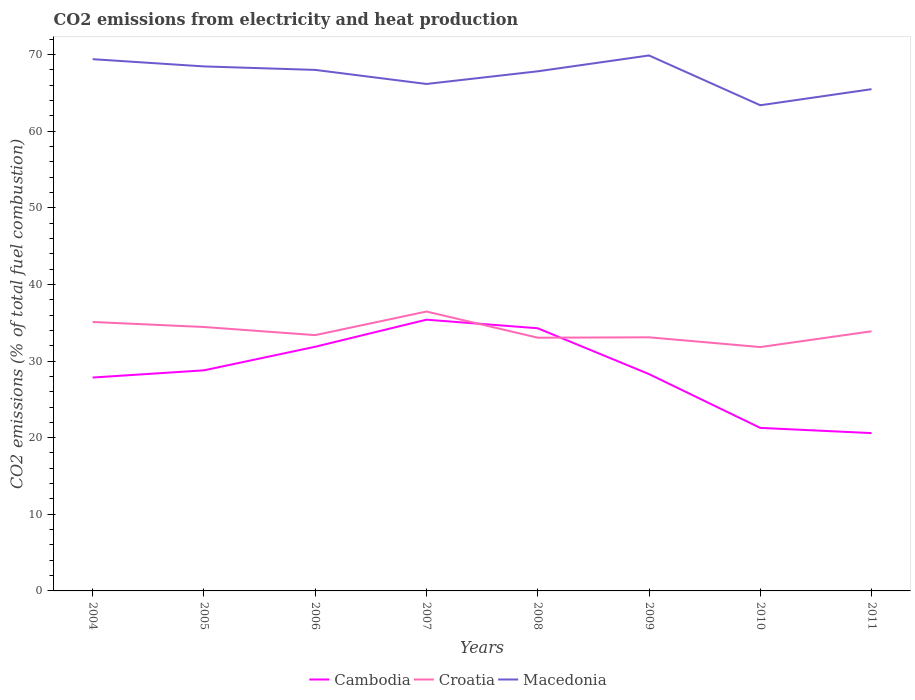Does the line corresponding to Macedonia intersect with the line corresponding to Cambodia?
Ensure brevity in your answer.  No. Is the number of lines equal to the number of legend labels?
Provide a succinct answer. Yes. Across all years, what is the maximum amount of CO2 emitted in Macedonia?
Give a very brief answer. 63.38. In which year was the amount of CO2 emitted in Croatia maximum?
Your answer should be very brief. 2010. What is the total amount of CO2 emitted in Croatia in the graph?
Provide a short and direct response. 3.37. What is the difference between the highest and the second highest amount of CO2 emitted in Croatia?
Give a very brief answer. 4.64. How many lines are there?
Ensure brevity in your answer.  3. How many years are there in the graph?
Give a very brief answer. 8. What is the difference between two consecutive major ticks on the Y-axis?
Ensure brevity in your answer.  10. Are the values on the major ticks of Y-axis written in scientific E-notation?
Provide a short and direct response. No. Where does the legend appear in the graph?
Make the answer very short. Bottom center. How many legend labels are there?
Your answer should be compact. 3. How are the legend labels stacked?
Keep it short and to the point. Horizontal. What is the title of the graph?
Offer a terse response. CO2 emissions from electricity and heat production. Does "Palau" appear as one of the legend labels in the graph?
Your answer should be compact. No. What is the label or title of the X-axis?
Offer a terse response. Years. What is the label or title of the Y-axis?
Give a very brief answer. CO2 emissions (% of total fuel combustion). What is the CO2 emissions (% of total fuel combustion) of Cambodia in 2004?
Make the answer very short. 27.85. What is the CO2 emissions (% of total fuel combustion) in Croatia in 2004?
Provide a short and direct response. 35.1. What is the CO2 emissions (% of total fuel combustion) in Macedonia in 2004?
Ensure brevity in your answer.  69.4. What is the CO2 emissions (% of total fuel combustion) in Cambodia in 2005?
Offer a terse response. 28.79. What is the CO2 emissions (% of total fuel combustion) in Croatia in 2005?
Offer a very short reply. 34.44. What is the CO2 emissions (% of total fuel combustion) in Macedonia in 2005?
Make the answer very short. 68.45. What is the CO2 emissions (% of total fuel combustion) in Cambodia in 2006?
Offer a very short reply. 31.86. What is the CO2 emissions (% of total fuel combustion) in Croatia in 2006?
Keep it short and to the point. 33.38. What is the CO2 emissions (% of total fuel combustion) in Macedonia in 2006?
Your answer should be very brief. 68. What is the CO2 emissions (% of total fuel combustion) of Cambodia in 2007?
Ensure brevity in your answer.  35.4. What is the CO2 emissions (% of total fuel combustion) in Croatia in 2007?
Your answer should be very brief. 36.46. What is the CO2 emissions (% of total fuel combustion) of Macedonia in 2007?
Your response must be concise. 66.16. What is the CO2 emissions (% of total fuel combustion) of Cambodia in 2008?
Your answer should be very brief. 34.28. What is the CO2 emissions (% of total fuel combustion) of Croatia in 2008?
Provide a succinct answer. 33.05. What is the CO2 emissions (% of total fuel combustion) in Macedonia in 2008?
Your answer should be compact. 67.81. What is the CO2 emissions (% of total fuel combustion) in Cambodia in 2009?
Make the answer very short. 28.3. What is the CO2 emissions (% of total fuel combustion) of Croatia in 2009?
Keep it short and to the point. 33.1. What is the CO2 emissions (% of total fuel combustion) in Macedonia in 2009?
Your answer should be compact. 69.88. What is the CO2 emissions (% of total fuel combustion) of Cambodia in 2010?
Your answer should be compact. 21.28. What is the CO2 emissions (% of total fuel combustion) of Croatia in 2010?
Your response must be concise. 31.83. What is the CO2 emissions (% of total fuel combustion) of Macedonia in 2010?
Give a very brief answer. 63.38. What is the CO2 emissions (% of total fuel combustion) of Cambodia in 2011?
Provide a succinct answer. 20.6. What is the CO2 emissions (% of total fuel combustion) of Croatia in 2011?
Give a very brief answer. 33.88. What is the CO2 emissions (% of total fuel combustion) of Macedonia in 2011?
Your answer should be very brief. 65.48. Across all years, what is the maximum CO2 emissions (% of total fuel combustion) in Cambodia?
Keep it short and to the point. 35.4. Across all years, what is the maximum CO2 emissions (% of total fuel combustion) in Croatia?
Your answer should be compact. 36.46. Across all years, what is the maximum CO2 emissions (% of total fuel combustion) in Macedonia?
Offer a very short reply. 69.88. Across all years, what is the minimum CO2 emissions (% of total fuel combustion) in Cambodia?
Your answer should be compact. 20.6. Across all years, what is the minimum CO2 emissions (% of total fuel combustion) of Croatia?
Provide a succinct answer. 31.83. Across all years, what is the minimum CO2 emissions (% of total fuel combustion) in Macedonia?
Ensure brevity in your answer.  63.38. What is the total CO2 emissions (% of total fuel combustion) of Cambodia in the graph?
Make the answer very short. 228.35. What is the total CO2 emissions (% of total fuel combustion) of Croatia in the graph?
Provide a short and direct response. 271.24. What is the total CO2 emissions (% of total fuel combustion) in Macedonia in the graph?
Provide a succinct answer. 538.56. What is the difference between the CO2 emissions (% of total fuel combustion) of Cambodia in 2004 and that in 2005?
Your response must be concise. -0.94. What is the difference between the CO2 emissions (% of total fuel combustion) of Croatia in 2004 and that in 2005?
Give a very brief answer. 0.66. What is the difference between the CO2 emissions (% of total fuel combustion) in Macedonia in 2004 and that in 2005?
Your answer should be compact. 0.94. What is the difference between the CO2 emissions (% of total fuel combustion) in Cambodia in 2004 and that in 2006?
Offer a very short reply. -4.02. What is the difference between the CO2 emissions (% of total fuel combustion) of Croatia in 2004 and that in 2006?
Make the answer very short. 1.72. What is the difference between the CO2 emissions (% of total fuel combustion) in Macedonia in 2004 and that in 2006?
Make the answer very short. 1.4. What is the difference between the CO2 emissions (% of total fuel combustion) of Cambodia in 2004 and that in 2007?
Give a very brief answer. -7.55. What is the difference between the CO2 emissions (% of total fuel combustion) in Croatia in 2004 and that in 2007?
Your answer should be very brief. -1.36. What is the difference between the CO2 emissions (% of total fuel combustion) of Macedonia in 2004 and that in 2007?
Ensure brevity in your answer.  3.23. What is the difference between the CO2 emissions (% of total fuel combustion) in Cambodia in 2004 and that in 2008?
Give a very brief answer. -6.43. What is the difference between the CO2 emissions (% of total fuel combustion) of Croatia in 2004 and that in 2008?
Ensure brevity in your answer.  2.05. What is the difference between the CO2 emissions (% of total fuel combustion) of Macedonia in 2004 and that in 2008?
Your response must be concise. 1.58. What is the difference between the CO2 emissions (% of total fuel combustion) of Cambodia in 2004 and that in 2009?
Your answer should be very brief. -0.45. What is the difference between the CO2 emissions (% of total fuel combustion) of Croatia in 2004 and that in 2009?
Make the answer very short. 2. What is the difference between the CO2 emissions (% of total fuel combustion) of Macedonia in 2004 and that in 2009?
Your answer should be compact. -0.49. What is the difference between the CO2 emissions (% of total fuel combustion) in Cambodia in 2004 and that in 2010?
Your response must be concise. 6.57. What is the difference between the CO2 emissions (% of total fuel combustion) in Croatia in 2004 and that in 2010?
Provide a short and direct response. 3.27. What is the difference between the CO2 emissions (% of total fuel combustion) of Macedonia in 2004 and that in 2010?
Your answer should be very brief. 6.01. What is the difference between the CO2 emissions (% of total fuel combustion) of Cambodia in 2004 and that in 2011?
Your answer should be compact. 7.25. What is the difference between the CO2 emissions (% of total fuel combustion) of Croatia in 2004 and that in 2011?
Keep it short and to the point. 1.21. What is the difference between the CO2 emissions (% of total fuel combustion) of Macedonia in 2004 and that in 2011?
Make the answer very short. 3.92. What is the difference between the CO2 emissions (% of total fuel combustion) of Cambodia in 2005 and that in 2006?
Keep it short and to the point. -3.08. What is the difference between the CO2 emissions (% of total fuel combustion) of Croatia in 2005 and that in 2006?
Provide a short and direct response. 1.06. What is the difference between the CO2 emissions (% of total fuel combustion) in Macedonia in 2005 and that in 2006?
Your answer should be very brief. 0.46. What is the difference between the CO2 emissions (% of total fuel combustion) of Cambodia in 2005 and that in 2007?
Provide a short and direct response. -6.61. What is the difference between the CO2 emissions (% of total fuel combustion) of Croatia in 2005 and that in 2007?
Offer a very short reply. -2.02. What is the difference between the CO2 emissions (% of total fuel combustion) of Macedonia in 2005 and that in 2007?
Keep it short and to the point. 2.29. What is the difference between the CO2 emissions (% of total fuel combustion) in Cambodia in 2005 and that in 2008?
Your answer should be compact. -5.49. What is the difference between the CO2 emissions (% of total fuel combustion) of Croatia in 2005 and that in 2008?
Your answer should be very brief. 1.4. What is the difference between the CO2 emissions (% of total fuel combustion) of Macedonia in 2005 and that in 2008?
Offer a terse response. 0.64. What is the difference between the CO2 emissions (% of total fuel combustion) in Cambodia in 2005 and that in 2009?
Give a very brief answer. 0.49. What is the difference between the CO2 emissions (% of total fuel combustion) in Croatia in 2005 and that in 2009?
Your response must be concise. 1.35. What is the difference between the CO2 emissions (% of total fuel combustion) of Macedonia in 2005 and that in 2009?
Provide a succinct answer. -1.43. What is the difference between the CO2 emissions (% of total fuel combustion) of Cambodia in 2005 and that in 2010?
Your answer should be very brief. 7.51. What is the difference between the CO2 emissions (% of total fuel combustion) in Croatia in 2005 and that in 2010?
Keep it short and to the point. 2.62. What is the difference between the CO2 emissions (% of total fuel combustion) of Macedonia in 2005 and that in 2010?
Provide a succinct answer. 5.07. What is the difference between the CO2 emissions (% of total fuel combustion) of Cambodia in 2005 and that in 2011?
Make the answer very short. 8.19. What is the difference between the CO2 emissions (% of total fuel combustion) in Croatia in 2005 and that in 2011?
Give a very brief answer. 0.56. What is the difference between the CO2 emissions (% of total fuel combustion) of Macedonia in 2005 and that in 2011?
Ensure brevity in your answer.  2.97. What is the difference between the CO2 emissions (% of total fuel combustion) in Cambodia in 2006 and that in 2007?
Give a very brief answer. -3.53. What is the difference between the CO2 emissions (% of total fuel combustion) of Croatia in 2006 and that in 2007?
Provide a succinct answer. -3.08. What is the difference between the CO2 emissions (% of total fuel combustion) in Macedonia in 2006 and that in 2007?
Your answer should be very brief. 1.83. What is the difference between the CO2 emissions (% of total fuel combustion) in Cambodia in 2006 and that in 2008?
Give a very brief answer. -2.41. What is the difference between the CO2 emissions (% of total fuel combustion) in Croatia in 2006 and that in 2008?
Your answer should be compact. 0.33. What is the difference between the CO2 emissions (% of total fuel combustion) in Macedonia in 2006 and that in 2008?
Your response must be concise. 0.18. What is the difference between the CO2 emissions (% of total fuel combustion) of Cambodia in 2006 and that in 2009?
Provide a short and direct response. 3.57. What is the difference between the CO2 emissions (% of total fuel combustion) in Croatia in 2006 and that in 2009?
Your answer should be compact. 0.28. What is the difference between the CO2 emissions (% of total fuel combustion) of Macedonia in 2006 and that in 2009?
Give a very brief answer. -1.89. What is the difference between the CO2 emissions (% of total fuel combustion) in Cambodia in 2006 and that in 2010?
Provide a short and direct response. 10.59. What is the difference between the CO2 emissions (% of total fuel combustion) in Croatia in 2006 and that in 2010?
Provide a succinct answer. 1.56. What is the difference between the CO2 emissions (% of total fuel combustion) in Macedonia in 2006 and that in 2010?
Provide a short and direct response. 4.61. What is the difference between the CO2 emissions (% of total fuel combustion) of Cambodia in 2006 and that in 2011?
Your answer should be compact. 11.27. What is the difference between the CO2 emissions (% of total fuel combustion) of Croatia in 2006 and that in 2011?
Your response must be concise. -0.5. What is the difference between the CO2 emissions (% of total fuel combustion) in Macedonia in 2006 and that in 2011?
Offer a terse response. 2.52. What is the difference between the CO2 emissions (% of total fuel combustion) in Cambodia in 2007 and that in 2008?
Provide a short and direct response. 1.12. What is the difference between the CO2 emissions (% of total fuel combustion) in Croatia in 2007 and that in 2008?
Your answer should be compact. 3.42. What is the difference between the CO2 emissions (% of total fuel combustion) of Macedonia in 2007 and that in 2008?
Your answer should be compact. -1.65. What is the difference between the CO2 emissions (% of total fuel combustion) of Cambodia in 2007 and that in 2009?
Offer a terse response. 7.1. What is the difference between the CO2 emissions (% of total fuel combustion) of Croatia in 2007 and that in 2009?
Offer a very short reply. 3.37. What is the difference between the CO2 emissions (% of total fuel combustion) in Macedonia in 2007 and that in 2009?
Keep it short and to the point. -3.72. What is the difference between the CO2 emissions (% of total fuel combustion) of Cambodia in 2007 and that in 2010?
Provide a succinct answer. 14.12. What is the difference between the CO2 emissions (% of total fuel combustion) of Croatia in 2007 and that in 2010?
Offer a very short reply. 4.64. What is the difference between the CO2 emissions (% of total fuel combustion) of Macedonia in 2007 and that in 2010?
Your answer should be compact. 2.78. What is the difference between the CO2 emissions (% of total fuel combustion) in Cambodia in 2007 and that in 2011?
Your answer should be very brief. 14.8. What is the difference between the CO2 emissions (% of total fuel combustion) in Croatia in 2007 and that in 2011?
Offer a very short reply. 2.58. What is the difference between the CO2 emissions (% of total fuel combustion) in Macedonia in 2007 and that in 2011?
Make the answer very short. 0.68. What is the difference between the CO2 emissions (% of total fuel combustion) of Cambodia in 2008 and that in 2009?
Offer a terse response. 5.98. What is the difference between the CO2 emissions (% of total fuel combustion) in Macedonia in 2008 and that in 2009?
Your answer should be compact. -2.07. What is the difference between the CO2 emissions (% of total fuel combustion) of Cambodia in 2008 and that in 2010?
Give a very brief answer. 13. What is the difference between the CO2 emissions (% of total fuel combustion) in Croatia in 2008 and that in 2010?
Your answer should be very brief. 1.22. What is the difference between the CO2 emissions (% of total fuel combustion) in Macedonia in 2008 and that in 2010?
Your answer should be very brief. 4.43. What is the difference between the CO2 emissions (% of total fuel combustion) of Cambodia in 2008 and that in 2011?
Offer a very short reply. 13.68. What is the difference between the CO2 emissions (% of total fuel combustion) of Croatia in 2008 and that in 2011?
Provide a succinct answer. -0.84. What is the difference between the CO2 emissions (% of total fuel combustion) in Macedonia in 2008 and that in 2011?
Your response must be concise. 2.33. What is the difference between the CO2 emissions (% of total fuel combustion) in Cambodia in 2009 and that in 2010?
Make the answer very short. 7.02. What is the difference between the CO2 emissions (% of total fuel combustion) of Croatia in 2009 and that in 2010?
Ensure brevity in your answer.  1.27. What is the difference between the CO2 emissions (% of total fuel combustion) in Macedonia in 2009 and that in 2010?
Provide a succinct answer. 6.5. What is the difference between the CO2 emissions (% of total fuel combustion) of Cambodia in 2009 and that in 2011?
Offer a very short reply. 7.7. What is the difference between the CO2 emissions (% of total fuel combustion) in Croatia in 2009 and that in 2011?
Your answer should be very brief. -0.79. What is the difference between the CO2 emissions (% of total fuel combustion) in Macedonia in 2009 and that in 2011?
Ensure brevity in your answer.  4.4. What is the difference between the CO2 emissions (% of total fuel combustion) of Cambodia in 2010 and that in 2011?
Make the answer very short. 0.68. What is the difference between the CO2 emissions (% of total fuel combustion) of Croatia in 2010 and that in 2011?
Offer a terse response. -2.06. What is the difference between the CO2 emissions (% of total fuel combustion) of Macedonia in 2010 and that in 2011?
Provide a succinct answer. -2.1. What is the difference between the CO2 emissions (% of total fuel combustion) in Cambodia in 2004 and the CO2 emissions (% of total fuel combustion) in Croatia in 2005?
Offer a terse response. -6.59. What is the difference between the CO2 emissions (% of total fuel combustion) in Cambodia in 2004 and the CO2 emissions (% of total fuel combustion) in Macedonia in 2005?
Provide a short and direct response. -40.6. What is the difference between the CO2 emissions (% of total fuel combustion) of Croatia in 2004 and the CO2 emissions (% of total fuel combustion) of Macedonia in 2005?
Give a very brief answer. -33.35. What is the difference between the CO2 emissions (% of total fuel combustion) of Cambodia in 2004 and the CO2 emissions (% of total fuel combustion) of Croatia in 2006?
Provide a short and direct response. -5.53. What is the difference between the CO2 emissions (% of total fuel combustion) in Cambodia in 2004 and the CO2 emissions (% of total fuel combustion) in Macedonia in 2006?
Ensure brevity in your answer.  -40.15. What is the difference between the CO2 emissions (% of total fuel combustion) in Croatia in 2004 and the CO2 emissions (% of total fuel combustion) in Macedonia in 2006?
Offer a terse response. -32.9. What is the difference between the CO2 emissions (% of total fuel combustion) of Cambodia in 2004 and the CO2 emissions (% of total fuel combustion) of Croatia in 2007?
Provide a succinct answer. -8.61. What is the difference between the CO2 emissions (% of total fuel combustion) in Cambodia in 2004 and the CO2 emissions (% of total fuel combustion) in Macedonia in 2007?
Offer a terse response. -38.31. What is the difference between the CO2 emissions (% of total fuel combustion) in Croatia in 2004 and the CO2 emissions (% of total fuel combustion) in Macedonia in 2007?
Provide a succinct answer. -31.06. What is the difference between the CO2 emissions (% of total fuel combustion) of Cambodia in 2004 and the CO2 emissions (% of total fuel combustion) of Croatia in 2008?
Provide a succinct answer. -5.2. What is the difference between the CO2 emissions (% of total fuel combustion) in Cambodia in 2004 and the CO2 emissions (% of total fuel combustion) in Macedonia in 2008?
Provide a succinct answer. -39.97. What is the difference between the CO2 emissions (% of total fuel combustion) in Croatia in 2004 and the CO2 emissions (% of total fuel combustion) in Macedonia in 2008?
Provide a short and direct response. -32.72. What is the difference between the CO2 emissions (% of total fuel combustion) in Cambodia in 2004 and the CO2 emissions (% of total fuel combustion) in Croatia in 2009?
Your answer should be compact. -5.25. What is the difference between the CO2 emissions (% of total fuel combustion) of Cambodia in 2004 and the CO2 emissions (% of total fuel combustion) of Macedonia in 2009?
Make the answer very short. -42.03. What is the difference between the CO2 emissions (% of total fuel combustion) in Croatia in 2004 and the CO2 emissions (% of total fuel combustion) in Macedonia in 2009?
Offer a very short reply. -34.78. What is the difference between the CO2 emissions (% of total fuel combustion) of Cambodia in 2004 and the CO2 emissions (% of total fuel combustion) of Croatia in 2010?
Your response must be concise. -3.98. What is the difference between the CO2 emissions (% of total fuel combustion) in Cambodia in 2004 and the CO2 emissions (% of total fuel combustion) in Macedonia in 2010?
Offer a terse response. -35.53. What is the difference between the CO2 emissions (% of total fuel combustion) of Croatia in 2004 and the CO2 emissions (% of total fuel combustion) of Macedonia in 2010?
Your answer should be very brief. -28.28. What is the difference between the CO2 emissions (% of total fuel combustion) of Cambodia in 2004 and the CO2 emissions (% of total fuel combustion) of Croatia in 2011?
Your response must be concise. -6.04. What is the difference between the CO2 emissions (% of total fuel combustion) of Cambodia in 2004 and the CO2 emissions (% of total fuel combustion) of Macedonia in 2011?
Your answer should be compact. -37.63. What is the difference between the CO2 emissions (% of total fuel combustion) of Croatia in 2004 and the CO2 emissions (% of total fuel combustion) of Macedonia in 2011?
Keep it short and to the point. -30.38. What is the difference between the CO2 emissions (% of total fuel combustion) of Cambodia in 2005 and the CO2 emissions (% of total fuel combustion) of Croatia in 2006?
Make the answer very short. -4.59. What is the difference between the CO2 emissions (% of total fuel combustion) of Cambodia in 2005 and the CO2 emissions (% of total fuel combustion) of Macedonia in 2006?
Keep it short and to the point. -39.21. What is the difference between the CO2 emissions (% of total fuel combustion) of Croatia in 2005 and the CO2 emissions (% of total fuel combustion) of Macedonia in 2006?
Provide a short and direct response. -33.55. What is the difference between the CO2 emissions (% of total fuel combustion) in Cambodia in 2005 and the CO2 emissions (% of total fuel combustion) in Croatia in 2007?
Keep it short and to the point. -7.67. What is the difference between the CO2 emissions (% of total fuel combustion) in Cambodia in 2005 and the CO2 emissions (% of total fuel combustion) in Macedonia in 2007?
Offer a terse response. -37.37. What is the difference between the CO2 emissions (% of total fuel combustion) of Croatia in 2005 and the CO2 emissions (% of total fuel combustion) of Macedonia in 2007?
Your answer should be compact. -31.72. What is the difference between the CO2 emissions (% of total fuel combustion) of Cambodia in 2005 and the CO2 emissions (% of total fuel combustion) of Croatia in 2008?
Your response must be concise. -4.26. What is the difference between the CO2 emissions (% of total fuel combustion) of Cambodia in 2005 and the CO2 emissions (% of total fuel combustion) of Macedonia in 2008?
Provide a succinct answer. -39.03. What is the difference between the CO2 emissions (% of total fuel combustion) in Croatia in 2005 and the CO2 emissions (% of total fuel combustion) in Macedonia in 2008?
Give a very brief answer. -33.37. What is the difference between the CO2 emissions (% of total fuel combustion) in Cambodia in 2005 and the CO2 emissions (% of total fuel combustion) in Croatia in 2009?
Your response must be concise. -4.31. What is the difference between the CO2 emissions (% of total fuel combustion) in Cambodia in 2005 and the CO2 emissions (% of total fuel combustion) in Macedonia in 2009?
Keep it short and to the point. -41.09. What is the difference between the CO2 emissions (% of total fuel combustion) in Croatia in 2005 and the CO2 emissions (% of total fuel combustion) in Macedonia in 2009?
Offer a terse response. -35.44. What is the difference between the CO2 emissions (% of total fuel combustion) of Cambodia in 2005 and the CO2 emissions (% of total fuel combustion) of Croatia in 2010?
Provide a succinct answer. -3.04. What is the difference between the CO2 emissions (% of total fuel combustion) in Cambodia in 2005 and the CO2 emissions (% of total fuel combustion) in Macedonia in 2010?
Ensure brevity in your answer.  -34.59. What is the difference between the CO2 emissions (% of total fuel combustion) of Croatia in 2005 and the CO2 emissions (% of total fuel combustion) of Macedonia in 2010?
Offer a very short reply. -28.94. What is the difference between the CO2 emissions (% of total fuel combustion) in Cambodia in 2005 and the CO2 emissions (% of total fuel combustion) in Croatia in 2011?
Give a very brief answer. -5.1. What is the difference between the CO2 emissions (% of total fuel combustion) in Cambodia in 2005 and the CO2 emissions (% of total fuel combustion) in Macedonia in 2011?
Provide a succinct answer. -36.69. What is the difference between the CO2 emissions (% of total fuel combustion) in Croatia in 2005 and the CO2 emissions (% of total fuel combustion) in Macedonia in 2011?
Your response must be concise. -31.04. What is the difference between the CO2 emissions (% of total fuel combustion) in Cambodia in 2006 and the CO2 emissions (% of total fuel combustion) in Croatia in 2007?
Your answer should be compact. -4.6. What is the difference between the CO2 emissions (% of total fuel combustion) in Cambodia in 2006 and the CO2 emissions (% of total fuel combustion) in Macedonia in 2007?
Offer a very short reply. -34.3. What is the difference between the CO2 emissions (% of total fuel combustion) of Croatia in 2006 and the CO2 emissions (% of total fuel combustion) of Macedonia in 2007?
Ensure brevity in your answer.  -32.78. What is the difference between the CO2 emissions (% of total fuel combustion) of Cambodia in 2006 and the CO2 emissions (% of total fuel combustion) of Croatia in 2008?
Give a very brief answer. -1.18. What is the difference between the CO2 emissions (% of total fuel combustion) in Cambodia in 2006 and the CO2 emissions (% of total fuel combustion) in Macedonia in 2008?
Your answer should be compact. -35.95. What is the difference between the CO2 emissions (% of total fuel combustion) of Croatia in 2006 and the CO2 emissions (% of total fuel combustion) of Macedonia in 2008?
Make the answer very short. -34.43. What is the difference between the CO2 emissions (% of total fuel combustion) of Cambodia in 2006 and the CO2 emissions (% of total fuel combustion) of Croatia in 2009?
Your answer should be very brief. -1.23. What is the difference between the CO2 emissions (% of total fuel combustion) in Cambodia in 2006 and the CO2 emissions (% of total fuel combustion) in Macedonia in 2009?
Offer a very short reply. -38.02. What is the difference between the CO2 emissions (% of total fuel combustion) of Croatia in 2006 and the CO2 emissions (% of total fuel combustion) of Macedonia in 2009?
Offer a very short reply. -36.5. What is the difference between the CO2 emissions (% of total fuel combustion) in Cambodia in 2006 and the CO2 emissions (% of total fuel combustion) in Croatia in 2010?
Your response must be concise. 0.04. What is the difference between the CO2 emissions (% of total fuel combustion) of Cambodia in 2006 and the CO2 emissions (% of total fuel combustion) of Macedonia in 2010?
Your answer should be very brief. -31.52. What is the difference between the CO2 emissions (% of total fuel combustion) in Croatia in 2006 and the CO2 emissions (% of total fuel combustion) in Macedonia in 2010?
Offer a very short reply. -30. What is the difference between the CO2 emissions (% of total fuel combustion) in Cambodia in 2006 and the CO2 emissions (% of total fuel combustion) in Croatia in 2011?
Your answer should be very brief. -2.02. What is the difference between the CO2 emissions (% of total fuel combustion) of Cambodia in 2006 and the CO2 emissions (% of total fuel combustion) of Macedonia in 2011?
Keep it short and to the point. -33.62. What is the difference between the CO2 emissions (% of total fuel combustion) in Croatia in 2006 and the CO2 emissions (% of total fuel combustion) in Macedonia in 2011?
Your response must be concise. -32.1. What is the difference between the CO2 emissions (% of total fuel combustion) of Cambodia in 2007 and the CO2 emissions (% of total fuel combustion) of Croatia in 2008?
Make the answer very short. 2.35. What is the difference between the CO2 emissions (% of total fuel combustion) of Cambodia in 2007 and the CO2 emissions (% of total fuel combustion) of Macedonia in 2008?
Your answer should be compact. -32.42. What is the difference between the CO2 emissions (% of total fuel combustion) in Croatia in 2007 and the CO2 emissions (% of total fuel combustion) in Macedonia in 2008?
Make the answer very short. -31.35. What is the difference between the CO2 emissions (% of total fuel combustion) in Cambodia in 2007 and the CO2 emissions (% of total fuel combustion) in Croatia in 2009?
Your answer should be very brief. 2.3. What is the difference between the CO2 emissions (% of total fuel combustion) in Cambodia in 2007 and the CO2 emissions (% of total fuel combustion) in Macedonia in 2009?
Make the answer very short. -34.48. What is the difference between the CO2 emissions (% of total fuel combustion) in Croatia in 2007 and the CO2 emissions (% of total fuel combustion) in Macedonia in 2009?
Your answer should be compact. -33.42. What is the difference between the CO2 emissions (% of total fuel combustion) of Cambodia in 2007 and the CO2 emissions (% of total fuel combustion) of Croatia in 2010?
Provide a short and direct response. 3.57. What is the difference between the CO2 emissions (% of total fuel combustion) of Cambodia in 2007 and the CO2 emissions (% of total fuel combustion) of Macedonia in 2010?
Offer a very short reply. -27.98. What is the difference between the CO2 emissions (% of total fuel combustion) in Croatia in 2007 and the CO2 emissions (% of total fuel combustion) in Macedonia in 2010?
Keep it short and to the point. -26.92. What is the difference between the CO2 emissions (% of total fuel combustion) of Cambodia in 2007 and the CO2 emissions (% of total fuel combustion) of Croatia in 2011?
Your response must be concise. 1.51. What is the difference between the CO2 emissions (% of total fuel combustion) of Cambodia in 2007 and the CO2 emissions (% of total fuel combustion) of Macedonia in 2011?
Keep it short and to the point. -30.08. What is the difference between the CO2 emissions (% of total fuel combustion) in Croatia in 2007 and the CO2 emissions (% of total fuel combustion) in Macedonia in 2011?
Offer a very short reply. -29.02. What is the difference between the CO2 emissions (% of total fuel combustion) in Cambodia in 2008 and the CO2 emissions (% of total fuel combustion) in Croatia in 2009?
Offer a terse response. 1.18. What is the difference between the CO2 emissions (% of total fuel combustion) in Cambodia in 2008 and the CO2 emissions (% of total fuel combustion) in Macedonia in 2009?
Your answer should be very brief. -35.6. What is the difference between the CO2 emissions (% of total fuel combustion) in Croatia in 2008 and the CO2 emissions (% of total fuel combustion) in Macedonia in 2009?
Keep it short and to the point. -36.83. What is the difference between the CO2 emissions (% of total fuel combustion) of Cambodia in 2008 and the CO2 emissions (% of total fuel combustion) of Croatia in 2010?
Offer a terse response. 2.45. What is the difference between the CO2 emissions (% of total fuel combustion) in Cambodia in 2008 and the CO2 emissions (% of total fuel combustion) in Macedonia in 2010?
Offer a very short reply. -29.1. What is the difference between the CO2 emissions (% of total fuel combustion) in Croatia in 2008 and the CO2 emissions (% of total fuel combustion) in Macedonia in 2010?
Make the answer very short. -30.33. What is the difference between the CO2 emissions (% of total fuel combustion) in Cambodia in 2008 and the CO2 emissions (% of total fuel combustion) in Croatia in 2011?
Make the answer very short. 0.39. What is the difference between the CO2 emissions (% of total fuel combustion) of Cambodia in 2008 and the CO2 emissions (% of total fuel combustion) of Macedonia in 2011?
Provide a succinct answer. -31.2. What is the difference between the CO2 emissions (% of total fuel combustion) in Croatia in 2008 and the CO2 emissions (% of total fuel combustion) in Macedonia in 2011?
Offer a terse response. -32.43. What is the difference between the CO2 emissions (% of total fuel combustion) in Cambodia in 2009 and the CO2 emissions (% of total fuel combustion) in Croatia in 2010?
Make the answer very short. -3.53. What is the difference between the CO2 emissions (% of total fuel combustion) in Cambodia in 2009 and the CO2 emissions (% of total fuel combustion) in Macedonia in 2010?
Your response must be concise. -35.09. What is the difference between the CO2 emissions (% of total fuel combustion) of Croatia in 2009 and the CO2 emissions (% of total fuel combustion) of Macedonia in 2010?
Provide a short and direct response. -30.28. What is the difference between the CO2 emissions (% of total fuel combustion) in Cambodia in 2009 and the CO2 emissions (% of total fuel combustion) in Croatia in 2011?
Your response must be concise. -5.59. What is the difference between the CO2 emissions (% of total fuel combustion) of Cambodia in 2009 and the CO2 emissions (% of total fuel combustion) of Macedonia in 2011?
Keep it short and to the point. -37.18. What is the difference between the CO2 emissions (% of total fuel combustion) of Croatia in 2009 and the CO2 emissions (% of total fuel combustion) of Macedonia in 2011?
Your answer should be very brief. -32.38. What is the difference between the CO2 emissions (% of total fuel combustion) in Cambodia in 2010 and the CO2 emissions (% of total fuel combustion) in Croatia in 2011?
Give a very brief answer. -12.61. What is the difference between the CO2 emissions (% of total fuel combustion) of Cambodia in 2010 and the CO2 emissions (% of total fuel combustion) of Macedonia in 2011?
Your response must be concise. -44.2. What is the difference between the CO2 emissions (% of total fuel combustion) in Croatia in 2010 and the CO2 emissions (% of total fuel combustion) in Macedonia in 2011?
Provide a short and direct response. -33.65. What is the average CO2 emissions (% of total fuel combustion) in Cambodia per year?
Offer a terse response. 28.54. What is the average CO2 emissions (% of total fuel combustion) in Croatia per year?
Provide a succinct answer. 33.9. What is the average CO2 emissions (% of total fuel combustion) in Macedonia per year?
Your answer should be very brief. 67.32. In the year 2004, what is the difference between the CO2 emissions (% of total fuel combustion) of Cambodia and CO2 emissions (% of total fuel combustion) of Croatia?
Offer a very short reply. -7.25. In the year 2004, what is the difference between the CO2 emissions (% of total fuel combustion) in Cambodia and CO2 emissions (% of total fuel combustion) in Macedonia?
Offer a terse response. -41.55. In the year 2004, what is the difference between the CO2 emissions (% of total fuel combustion) of Croatia and CO2 emissions (% of total fuel combustion) of Macedonia?
Provide a succinct answer. -34.3. In the year 2005, what is the difference between the CO2 emissions (% of total fuel combustion) in Cambodia and CO2 emissions (% of total fuel combustion) in Croatia?
Give a very brief answer. -5.66. In the year 2005, what is the difference between the CO2 emissions (% of total fuel combustion) of Cambodia and CO2 emissions (% of total fuel combustion) of Macedonia?
Your response must be concise. -39.66. In the year 2005, what is the difference between the CO2 emissions (% of total fuel combustion) of Croatia and CO2 emissions (% of total fuel combustion) of Macedonia?
Provide a short and direct response. -34.01. In the year 2006, what is the difference between the CO2 emissions (% of total fuel combustion) in Cambodia and CO2 emissions (% of total fuel combustion) in Croatia?
Provide a short and direct response. -1.52. In the year 2006, what is the difference between the CO2 emissions (% of total fuel combustion) in Cambodia and CO2 emissions (% of total fuel combustion) in Macedonia?
Make the answer very short. -36.13. In the year 2006, what is the difference between the CO2 emissions (% of total fuel combustion) in Croatia and CO2 emissions (% of total fuel combustion) in Macedonia?
Offer a very short reply. -34.61. In the year 2007, what is the difference between the CO2 emissions (% of total fuel combustion) of Cambodia and CO2 emissions (% of total fuel combustion) of Croatia?
Your response must be concise. -1.06. In the year 2007, what is the difference between the CO2 emissions (% of total fuel combustion) in Cambodia and CO2 emissions (% of total fuel combustion) in Macedonia?
Make the answer very short. -30.76. In the year 2007, what is the difference between the CO2 emissions (% of total fuel combustion) in Croatia and CO2 emissions (% of total fuel combustion) in Macedonia?
Make the answer very short. -29.7. In the year 2008, what is the difference between the CO2 emissions (% of total fuel combustion) of Cambodia and CO2 emissions (% of total fuel combustion) of Croatia?
Provide a succinct answer. 1.23. In the year 2008, what is the difference between the CO2 emissions (% of total fuel combustion) of Cambodia and CO2 emissions (% of total fuel combustion) of Macedonia?
Your answer should be very brief. -33.54. In the year 2008, what is the difference between the CO2 emissions (% of total fuel combustion) in Croatia and CO2 emissions (% of total fuel combustion) in Macedonia?
Your response must be concise. -34.77. In the year 2009, what is the difference between the CO2 emissions (% of total fuel combustion) of Cambodia and CO2 emissions (% of total fuel combustion) of Croatia?
Your answer should be compact. -4.8. In the year 2009, what is the difference between the CO2 emissions (% of total fuel combustion) of Cambodia and CO2 emissions (% of total fuel combustion) of Macedonia?
Ensure brevity in your answer.  -41.58. In the year 2009, what is the difference between the CO2 emissions (% of total fuel combustion) of Croatia and CO2 emissions (% of total fuel combustion) of Macedonia?
Offer a terse response. -36.78. In the year 2010, what is the difference between the CO2 emissions (% of total fuel combustion) of Cambodia and CO2 emissions (% of total fuel combustion) of Croatia?
Your answer should be compact. -10.55. In the year 2010, what is the difference between the CO2 emissions (% of total fuel combustion) in Cambodia and CO2 emissions (% of total fuel combustion) in Macedonia?
Your answer should be very brief. -42.11. In the year 2010, what is the difference between the CO2 emissions (% of total fuel combustion) of Croatia and CO2 emissions (% of total fuel combustion) of Macedonia?
Provide a succinct answer. -31.56. In the year 2011, what is the difference between the CO2 emissions (% of total fuel combustion) in Cambodia and CO2 emissions (% of total fuel combustion) in Croatia?
Provide a succinct answer. -13.29. In the year 2011, what is the difference between the CO2 emissions (% of total fuel combustion) in Cambodia and CO2 emissions (% of total fuel combustion) in Macedonia?
Provide a short and direct response. -44.88. In the year 2011, what is the difference between the CO2 emissions (% of total fuel combustion) in Croatia and CO2 emissions (% of total fuel combustion) in Macedonia?
Offer a terse response. -31.6. What is the ratio of the CO2 emissions (% of total fuel combustion) of Cambodia in 2004 to that in 2005?
Your response must be concise. 0.97. What is the ratio of the CO2 emissions (% of total fuel combustion) in Macedonia in 2004 to that in 2005?
Your answer should be compact. 1.01. What is the ratio of the CO2 emissions (% of total fuel combustion) of Cambodia in 2004 to that in 2006?
Your answer should be compact. 0.87. What is the ratio of the CO2 emissions (% of total fuel combustion) of Croatia in 2004 to that in 2006?
Your response must be concise. 1.05. What is the ratio of the CO2 emissions (% of total fuel combustion) of Macedonia in 2004 to that in 2006?
Offer a very short reply. 1.02. What is the ratio of the CO2 emissions (% of total fuel combustion) of Cambodia in 2004 to that in 2007?
Provide a short and direct response. 0.79. What is the ratio of the CO2 emissions (% of total fuel combustion) in Croatia in 2004 to that in 2007?
Make the answer very short. 0.96. What is the ratio of the CO2 emissions (% of total fuel combustion) of Macedonia in 2004 to that in 2007?
Offer a very short reply. 1.05. What is the ratio of the CO2 emissions (% of total fuel combustion) in Cambodia in 2004 to that in 2008?
Offer a very short reply. 0.81. What is the ratio of the CO2 emissions (% of total fuel combustion) in Croatia in 2004 to that in 2008?
Offer a very short reply. 1.06. What is the ratio of the CO2 emissions (% of total fuel combustion) of Macedonia in 2004 to that in 2008?
Make the answer very short. 1.02. What is the ratio of the CO2 emissions (% of total fuel combustion) of Cambodia in 2004 to that in 2009?
Give a very brief answer. 0.98. What is the ratio of the CO2 emissions (% of total fuel combustion) in Croatia in 2004 to that in 2009?
Keep it short and to the point. 1.06. What is the ratio of the CO2 emissions (% of total fuel combustion) in Cambodia in 2004 to that in 2010?
Provide a succinct answer. 1.31. What is the ratio of the CO2 emissions (% of total fuel combustion) of Croatia in 2004 to that in 2010?
Your response must be concise. 1.1. What is the ratio of the CO2 emissions (% of total fuel combustion) of Macedonia in 2004 to that in 2010?
Make the answer very short. 1.09. What is the ratio of the CO2 emissions (% of total fuel combustion) in Cambodia in 2004 to that in 2011?
Offer a terse response. 1.35. What is the ratio of the CO2 emissions (% of total fuel combustion) in Croatia in 2004 to that in 2011?
Give a very brief answer. 1.04. What is the ratio of the CO2 emissions (% of total fuel combustion) of Macedonia in 2004 to that in 2011?
Your answer should be compact. 1.06. What is the ratio of the CO2 emissions (% of total fuel combustion) in Cambodia in 2005 to that in 2006?
Ensure brevity in your answer.  0.9. What is the ratio of the CO2 emissions (% of total fuel combustion) in Croatia in 2005 to that in 2006?
Your answer should be very brief. 1.03. What is the ratio of the CO2 emissions (% of total fuel combustion) of Cambodia in 2005 to that in 2007?
Ensure brevity in your answer.  0.81. What is the ratio of the CO2 emissions (% of total fuel combustion) in Croatia in 2005 to that in 2007?
Give a very brief answer. 0.94. What is the ratio of the CO2 emissions (% of total fuel combustion) of Macedonia in 2005 to that in 2007?
Provide a succinct answer. 1.03. What is the ratio of the CO2 emissions (% of total fuel combustion) of Cambodia in 2005 to that in 2008?
Make the answer very short. 0.84. What is the ratio of the CO2 emissions (% of total fuel combustion) in Croatia in 2005 to that in 2008?
Your answer should be very brief. 1.04. What is the ratio of the CO2 emissions (% of total fuel combustion) in Macedonia in 2005 to that in 2008?
Make the answer very short. 1.01. What is the ratio of the CO2 emissions (% of total fuel combustion) of Cambodia in 2005 to that in 2009?
Your answer should be compact. 1.02. What is the ratio of the CO2 emissions (% of total fuel combustion) of Croatia in 2005 to that in 2009?
Offer a terse response. 1.04. What is the ratio of the CO2 emissions (% of total fuel combustion) of Macedonia in 2005 to that in 2009?
Your answer should be very brief. 0.98. What is the ratio of the CO2 emissions (% of total fuel combustion) in Cambodia in 2005 to that in 2010?
Offer a very short reply. 1.35. What is the ratio of the CO2 emissions (% of total fuel combustion) in Croatia in 2005 to that in 2010?
Make the answer very short. 1.08. What is the ratio of the CO2 emissions (% of total fuel combustion) of Macedonia in 2005 to that in 2010?
Make the answer very short. 1.08. What is the ratio of the CO2 emissions (% of total fuel combustion) of Cambodia in 2005 to that in 2011?
Give a very brief answer. 1.4. What is the ratio of the CO2 emissions (% of total fuel combustion) in Croatia in 2005 to that in 2011?
Provide a short and direct response. 1.02. What is the ratio of the CO2 emissions (% of total fuel combustion) of Macedonia in 2005 to that in 2011?
Provide a short and direct response. 1.05. What is the ratio of the CO2 emissions (% of total fuel combustion) in Cambodia in 2006 to that in 2007?
Your response must be concise. 0.9. What is the ratio of the CO2 emissions (% of total fuel combustion) of Croatia in 2006 to that in 2007?
Offer a very short reply. 0.92. What is the ratio of the CO2 emissions (% of total fuel combustion) of Macedonia in 2006 to that in 2007?
Offer a terse response. 1.03. What is the ratio of the CO2 emissions (% of total fuel combustion) of Cambodia in 2006 to that in 2008?
Your answer should be very brief. 0.93. What is the ratio of the CO2 emissions (% of total fuel combustion) of Macedonia in 2006 to that in 2008?
Your answer should be compact. 1. What is the ratio of the CO2 emissions (% of total fuel combustion) of Cambodia in 2006 to that in 2009?
Offer a very short reply. 1.13. What is the ratio of the CO2 emissions (% of total fuel combustion) in Croatia in 2006 to that in 2009?
Provide a succinct answer. 1.01. What is the ratio of the CO2 emissions (% of total fuel combustion) of Macedonia in 2006 to that in 2009?
Your answer should be compact. 0.97. What is the ratio of the CO2 emissions (% of total fuel combustion) in Cambodia in 2006 to that in 2010?
Provide a succinct answer. 1.5. What is the ratio of the CO2 emissions (% of total fuel combustion) of Croatia in 2006 to that in 2010?
Make the answer very short. 1.05. What is the ratio of the CO2 emissions (% of total fuel combustion) of Macedonia in 2006 to that in 2010?
Ensure brevity in your answer.  1.07. What is the ratio of the CO2 emissions (% of total fuel combustion) of Cambodia in 2006 to that in 2011?
Provide a succinct answer. 1.55. What is the ratio of the CO2 emissions (% of total fuel combustion) of Croatia in 2006 to that in 2011?
Make the answer very short. 0.99. What is the ratio of the CO2 emissions (% of total fuel combustion) of Macedonia in 2006 to that in 2011?
Offer a terse response. 1.04. What is the ratio of the CO2 emissions (% of total fuel combustion) in Cambodia in 2007 to that in 2008?
Give a very brief answer. 1.03. What is the ratio of the CO2 emissions (% of total fuel combustion) of Croatia in 2007 to that in 2008?
Make the answer very short. 1.1. What is the ratio of the CO2 emissions (% of total fuel combustion) of Macedonia in 2007 to that in 2008?
Make the answer very short. 0.98. What is the ratio of the CO2 emissions (% of total fuel combustion) in Cambodia in 2007 to that in 2009?
Offer a very short reply. 1.25. What is the ratio of the CO2 emissions (% of total fuel combustion) in Croatia in 2007 to that in 2009?
Your answer should be very brief. 1.1. What is the ratio of the CO2 emissions (% of total fuel combustion) in Macedonia in 2007 to that in 2009?
Make the answer very short. 0.95. What is the ratio of the CO2 emissions (% of total fuel combustion) of Cambodia in 2007 to that in 2010?
Your answer should be very brief. 1.66. What is the ratio of the CO2 emissions (% of total fuel combustion) of Croatia in 2007 to that in 2010?
Make the answer very short. 1.15. What is the ratio of the CO2 emissions (% of total fuel combustion) in Macedonia in 2007 to that in 2010?
Offer a very short reply. 1.04. What is the ratio of the CO2 emissions (% of total fuel combustion) of Cambodia in 2007 to that in 2011?
Offer a very short reply. 1.72. What is the ratio of the CO2 emissions (% of total fuel combustion) of Croatia in 2007 to that in 2011?
Provide a succinct answer. 1.08. What is the ratio of the CO2 emissions (% of total fuel combustion) of Macedonia in 2007 to that in 2011?
Provide a succinct answer. 1.01. What is the ratio of the CO2 emissions (% of total fuel combustion) in Cambodia in 2008 to that in 2009?
Offer a terse response. 1.21. What is the ratio of the CO2 emissions (% of total fuel combustion) of Croatia in 2008 to that in 2009?
Provide a succinct answer. 1. What is the ratio of the CO2 emissions (% of total fuel combustion) in Macedonia in 2008 to that in 2009?
Provide a succinct answer. 0.97. What is the ratio of the CO2 emissions (% of total fuel combustion) of Cambodia in 2008 to that in 2010?
Provide a succinct answer. 1.61. What is the ratio of the CO2 emissions (% of total fuel combustion) in Croatia in 2008 to that in 2010?
Offer a terse response. 1.04. What is the ratio of the CO2 emissions (% of total fuel combustion) in Macedonia in 2008 to that in 2010?
Provide a short and direct response. 1.07. What is the ratio of the CO2 emissions (% of total fuel combustion) of Cambodia in 2008 to that in 2011?
Ensure brevity in your answer.  1.66. What is the ratio of the CO2 emissions (% of total fuel combustion) in Croatia in 2008 to that in 2011?
Provide a short and direct response. 0.98. What is the ratio of the CO2 emissions (% of total fuel combustion) of Macedonia in 2008 to that in 2011?
Your answer should be compact. 1.04. What is the ratio of the CO2 emissions (% of total fuel combustion) of Cambodia in 2009 to that in 2010?
Your response must be concise. 1.33. What is the ratio of the CO2 emissions (% of total fuel combustion) of Croatia in 2009 to that in 2010?
Offer a terse response. 1.04. What is the ratio of the CO2 emissions (% of total fuel combustion) in Macedonia in 2009 to that in 2010?
Give a very brief answer. 1.1. What is the ratio of the CO2 emissions (% of total fuel combustion) in Cambodia in 2009 to that in 2011?
Offer a terse response. 1.37. What is the ratio of the CO2 emissions (% of total fuel combustion) of Croatia in 2009 to that in 2011?
Give a very brief answer. 0.98. What is the ratio of the CO2 emissions (% of total fuel combustion) in Macedonia in 2009 to that in 2011?
Your response must be concise. 1.07. What is the ratio of the CO2 emissions (% of total fuel combustion) in Cambodia in 2010 to that in 2011?
Offer a very short reply. 1.03. What is the ratio of the CO2 emissions (% of total fuel combustion) in Croatia in 2010 to that in 2011?
Ensure brevity in your answer.  0.94. What is the ratio of the CO2 emissions (% of total fuel combustion) of Macedonia in 2010 to that in 2011?
Your response must be concise. 0.97. What is the difference between the highest and the second highest CO2 emissions (% of total fuel combustion) in Cambodia?
Offer a terse response. 1.12. What is the difference between the highest and the second highest CO2 emissions (% of total fuel combustion) in Croatia?
Offer a terse response. 1.36. What is the difference between the highest and the second highest CO2 emissions (% of total fuel combustion) in Macedonia?
Provide a succinct answer. 0.49. What is the difference between the highest and the lowest CO2 emissions (% of total fuel combustion) in Cambodia?
Offer a terse response. 14.8. What is the difference between the highest and the lowest CO2 emissions (% of total fuel combustion) in Croatia?
Provide a short and direct response. 4.64. What is the difference between the highest and the lowest CO2 emissions (% of total fuel combustion) of Macedonia?
Provide a succinct answer. 6.5. 